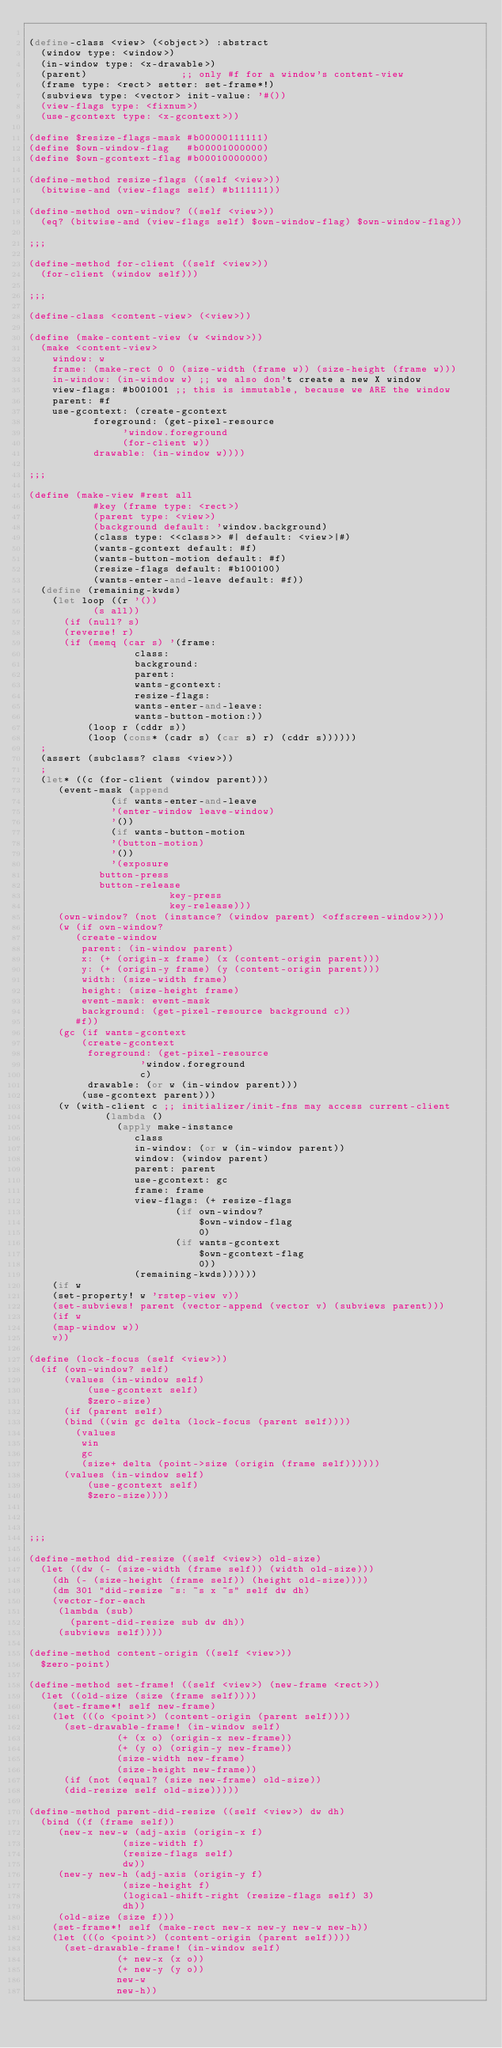Convert code to text. <code><loc_0><loc_0><loc_500><loc_500><_Scheme_>
(define-class <view> (<object>) :abstract
  (window type: <window>)
  (in-window type: <x-drawable>)
  (parent)                ;; only #f for a window's content-view
  (frame type: <rect> setter: set-frame*!)
  (subviews type: <vector> init-value: '#())
  (view-flags type: <fixnum>)
  (use-gcontext type: <x-gcontext>))

(define $resize-flags-mask #b00000111111)
(define $own-window-flag   #b00001000000)
(define $own-gcontext-flag #b00010000000)

(define-method resize-flags ((self <view>))
  (bitwise-and (view-flags self) #b111111))

(define-method own-window? ((self <view>))
  (eq? (bitwise-and (view-flags self) $own-window-flag) $own-window-flag))

;;;

(define-method for-client ((self <view>))
  (for-client (window self)))

;;;

(define-class <content-view> (<view>))

(define (make-content-view (w <window>))
  (make <content-view>
    window: w
    frame: (make-rect 0 0 (size-width (frame w)) (size-height (frame w)))
    in-window: (in-window w) ;; we also don't create a new X window
    view-flags: #b001001 ;; this is immutable, because we ARE the window
    parent: #f
    use-gcontext: (create-gcontext
		   foreground: (get-pixel-resource 
				'window.foreground
				(for-client w))
		   drawable: (in-window w))))

;;;

(define (make-view #rest all
		   #key (frame type: <rect>)
		   (parent type: <view>)
		   (background default: 'window.background)
		   (class type: <<class>> #| default: <view>|#)
		   (wants-gcontext default: #f)
		   (wants-button-motion default: #f)
		   (resize-flags default: #b100100)
		   (wants-enter-and-leave default: #f))
  (define (remaining-kwds)
    (let loop ((r '())
	       (s all))
      (if (null? s)
	  (reverse! r)
	  (if (memq (car s) '(frame: 
			      class:
			      background:
			      parent: 
			      wants-gcontext:
			      resize-flags:
			      wants-enter-and-leave:
			      wants-button-motion:))
	      (loop r (cddr s))
	      (loop (cons* (cadr s) (car s) r) (cddr s))))))
  ;
  (assert (subclass? class <view>))
  ;
  (let* ((c (for-client (window parent)))
	 (event-mask (append
		      (if wants-enter-and-leave 
			  '(enter-window leave-window) 
			  '())
		      (if wants-button-motion
			  '(button-motion)
			  '())
		      '(exposure
			button-press
			button-release
                        key-press
                        key-release)))
	 (own-window? (not (instance? (window parent) <offscreen-window>)))
	 (w (if own-window?
		(create-window 
		 parent: (in-window parent)
		 x: (+ (origin-x frame) (x (content-origin parent)))
		 y: (+ (origin-y frame) (y (content-origin parent)))
		 width: (size-width frame)
		 height: (size-height frame)
		 event-mask: event-mask
		 background: (get-pixel-resource background c))
		#f))
	 (gc (if wants-gcontext
		 (create-gcontext
		  foreground: (get-pixel-resource 
			       'window.foreground
			       c)
		  drawable: (or w (in-window parent)))
		 (use-gcontext parent)))
	 (v (with-client c ;; initializer/init-fns may access current-client
			 (lambda ()
			   (apply make-instance
				  class
				  in-window: (or w (in-window parent))
				  window: (window parent)
				  parent: parent
				  use-gcontext: gc
				  frame: frame
				  view-flags: (+ resize-flags
						 (if own-window?
						     $own-window-flag
						     0)
						 (if wants-gcontext
						     $own-gcontext-flag
						     0))
				  (remaining-kwds))))))
    (if w
	(set-property! w 'rstep-view v))
    (set-subviews! parent (vector-append (vector v) (subviews parent)))
    (if w
	(map-window w))
    v))

(define (lock-focus (self <view>))
  (if (own-window? self)
      (values (in-window self)
	      (use-gcontext self)
	      $zero-size)
      (if (parent self)
	  (bind ((win gc delta (lock-focus (parent self))))
	    (values
	     win
	     gc
	     (size+ delta (point->size (origin (frame self))))))
	  (values (in-window self)
		  (use-gcontext self)
		  $zero-size))))

		  
	  
;;;

(define-method did-resize ((self <view>) old-size)
  (let ((dw (- (size-width (frame self)) (width old-size)))
	(dh (- (size-height (frame self)) (height old-size))))
    (dm 301 "did-resize ~s: ~s x ~s" self dw dh)
    (vector-for-each
     (lambda (sub)
       (parent-did-resize sub dw dh))
     (subviews self))))

(define-method content-origin ((self <view>))
  $zero-point)

(define-method set-frame! ((self <view>) (new-frame <rect>))
  (let ((old-size (size (frame self))))
    (set-frame*! self new-frame)
    (let (((o <point>) (content-origin (parent self))))
      (set-drawable-frame! (in-window self)
			   (+ (x o) (origin-x new-frame))
			   (+ (y o) (origin-y new-frame))
			   (size-width new-frame)
			   (size-height new-frame))
      (if (not (equal? (size new-frame) old-size))
	  (did-resize self old-size)))))

(define-method parent-did-resize ((self <view>) dw dh)
  (bind ((f (frame self))
	 (new-x new-w (adj-axis (origin-x f)
				(size-width f)
				(resize-flags self)
				dw))
	 (new-y new-h (adj-axis (origin-y f)
				(size-height f) 
				(logical-shift-right (resize-flags self) 3)
				dh))
	 (old-size (size f)))
    (set-frame*! self (make-rect new-x new-y new-w new-h))
    (let (((o <point>) (content-origin (parent self))))
      (set-drawable-frame! (in-window self) 
			   (+ new-x (x o))
			   (+ new-y (y o))
			   new-w
			   new-h))</code> 